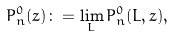<formula> <loc_0><loc_0><loc_500><loc_500>P _ { n } ^ { 0 } ( z ) \colon = \lim _ { L } P _ { n } ^ { 0 } ( L , z ) ,</formula> 